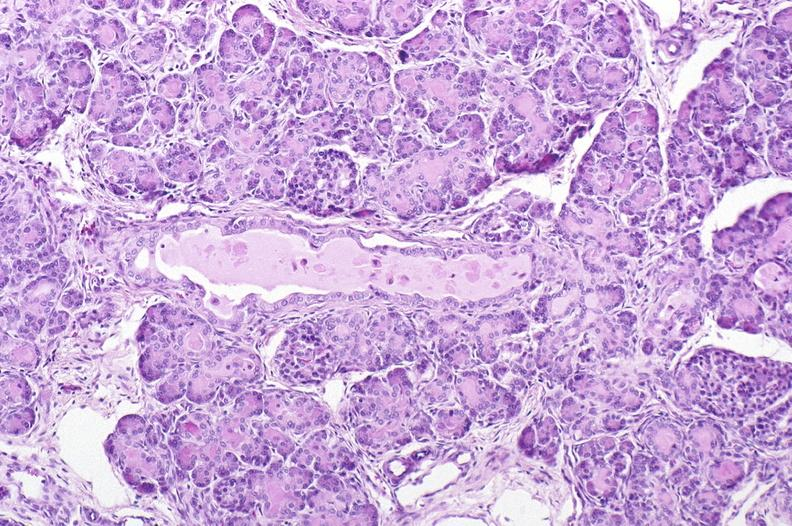s pancreas present?
Answer the question using a single word or phrase. Yes 